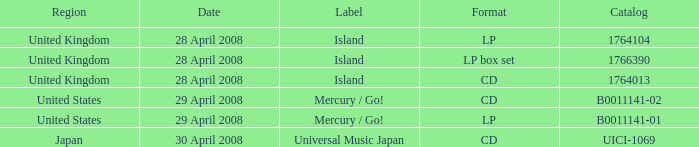What is the Label of the UICI-1069 Catalog? Universal Music Japan. 